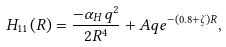<formula> <loc_0><loc_0><loc_500><loc_500>H _ { 1 1 } ( R ) = \frac { - \alpha _ { H } q ^ { 2 } } { 2 R ^ { 4 } } + A q e ^ { - ( 0 . 8 + \zeta ) R } ,</formula> 